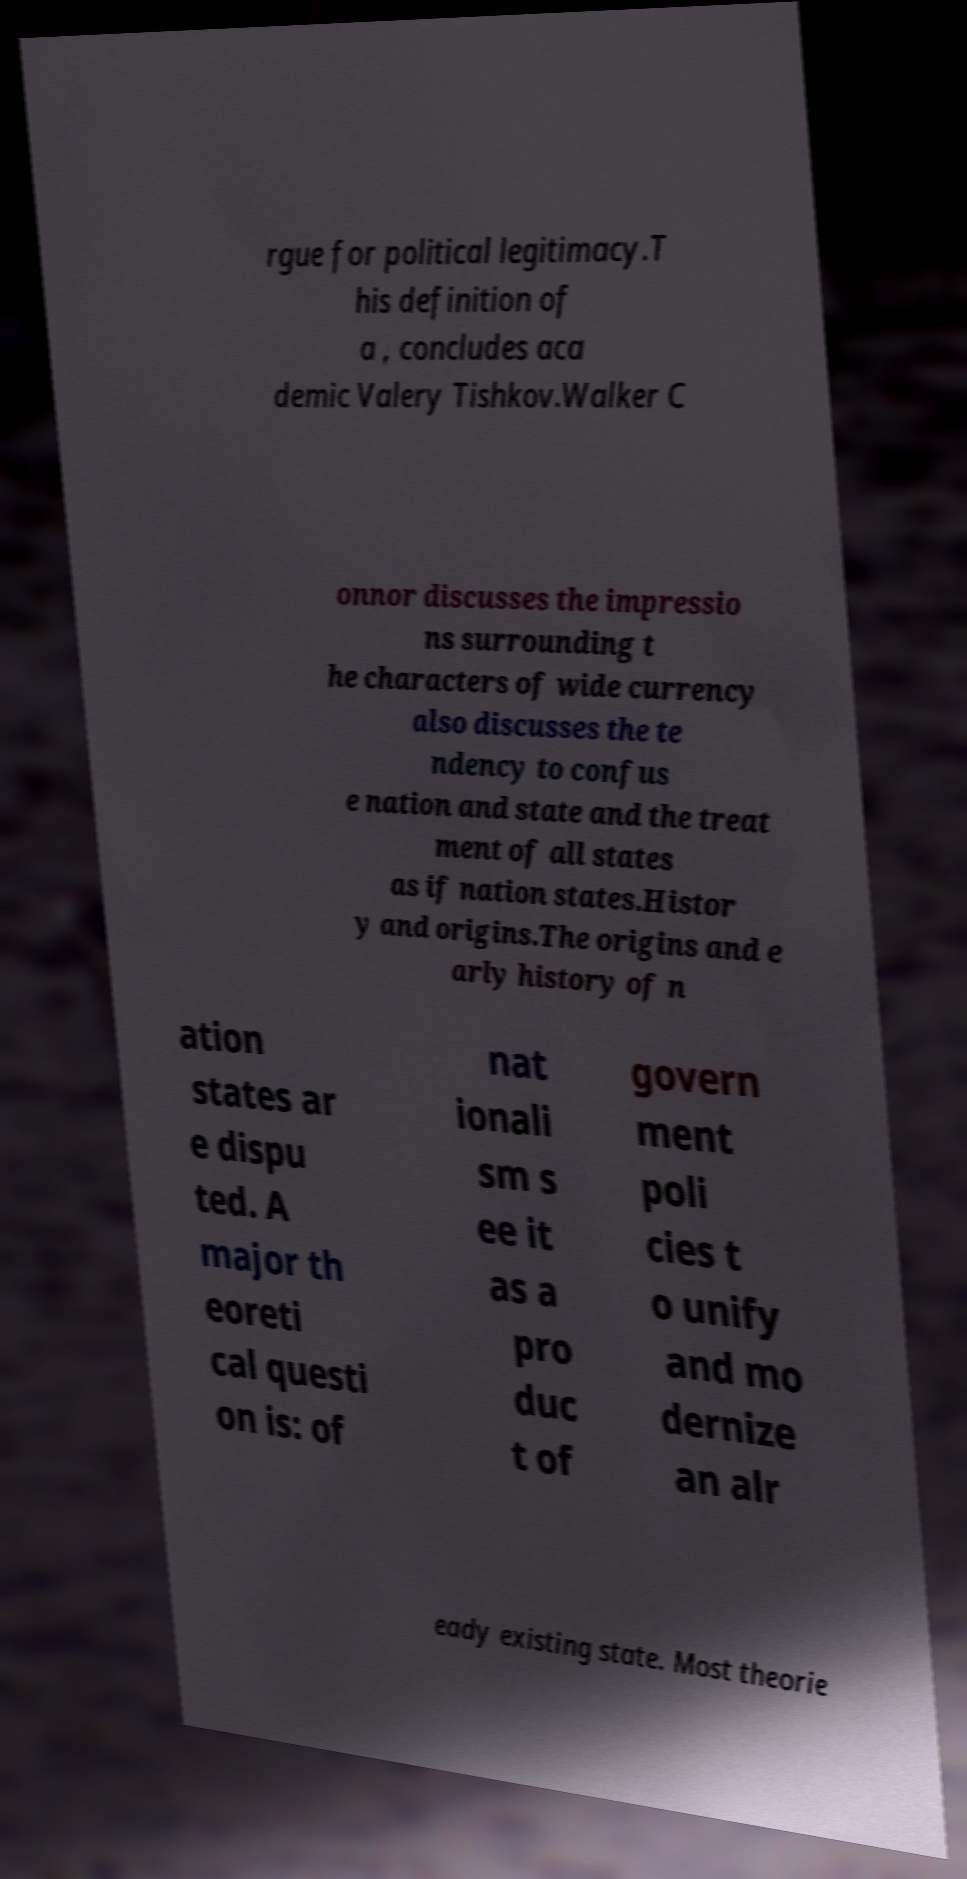Can you accurately transcribe the text from the provided image for me? rgue for political legitimacy.T his definition of a , concludes aca demic Valery Tishkov.Walker C onnor discusses the impressio ns surrounding t he characters of wide currency also discusses the te ndency to confus e nation and state and the treat ment of all states as if nation states.Histor y and origins.The origins and e arly history of n ation states ar e dispu ted. A major th eoreti cal questi on is: of nat ionali sm s ee it as a pro duc t of govern ment poli cies t o unify and mo dernize an alr eady existing state. Most theorie 